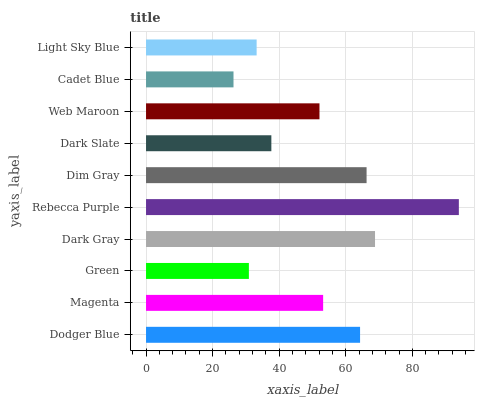Is Cadet Blue the minimum?
Answer yes or no. Yes. Is Rebecca Purple the maximum?
Answer yes or no. Yes. Is Magenta the minimum?
Answer yes or no. No. Is Magenta the maximum?
Answer yes or no. No. Is Dodger Blue greater than Magenta?
Answer yes or no. Yes. Is Magenta less than Dodger Blue?
Answer yes or no. Yes. Is Magenta greater than Dodger Blue?
Answer yes or no. No. Is Dodger Blue less than Magenta?
Answer yes or no. No. Is Magenta the high median?
Answer yes or no. Yes. Is Web Maroon the low median?
Answer yes or no. Yes. Is Dark Slate the high median?
Answer yes or no. No. Is Cadet Blue the low median?
Answer yes or no. No. 